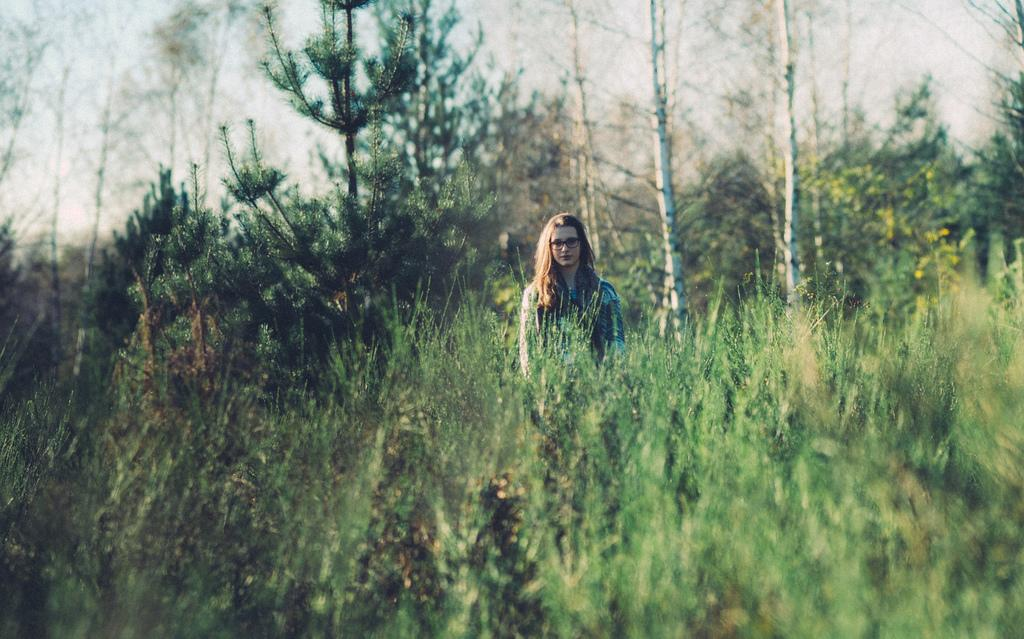Who is present in the image? There is a lady in the image. What type of natural environment is depicted in the image? There are many trees and plants in the image, suggesting a natural setting. What can be seen in the sky in the image? The sky is visible in the image. Can you see any giraffes in the image? No, there are no giraffes present in the image. What type of society is depicted in the image? The image does not depict any society; it primarily features a lady and natural elements. 